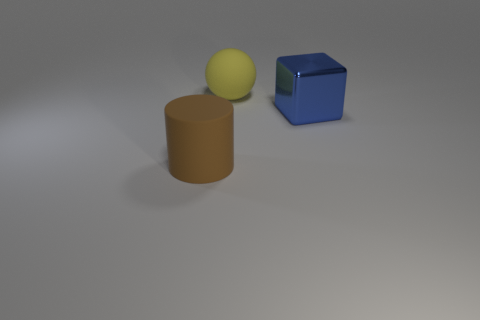Add 1 big cubes. How many objects exist? 4 Subtract all cubes. How many objects are left? 2 Subtract 1 blue cubes. How many objects are left? 2 Subtract all big purple rubber cylinders. Subtract all large brown objects. How many objects are left? 2 Add 2 cylinders. How many cylinders are left? 3 Add 2 large cyan rubber cubes. How many large cyan rubber cubes exist? 2 